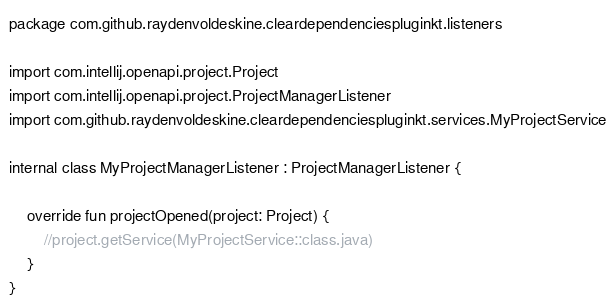Convert code to text. <code><loc_0><loc_0><loc_500><loc_500><_Kotlin_>package com.github.raydenvoldeskine.cleardependenciespluginkt.listeners

import com.intellij.openapi.project.Project
import com.intellij.openapi.project.ProjectManagerListener
import com.github.raydenvoldeskine.cleardependenciespluginkt.services.MyProjectService

internal class MyProjectManagerListener : ProjectManagerListener {

    override fun projectOpened(project: Project) {
        //project.getService(MyProjectService::class.java)
    }
}
</code> 